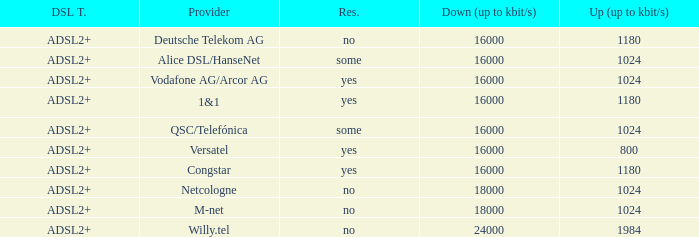What is the resale category for the provider NetCologne? No. 